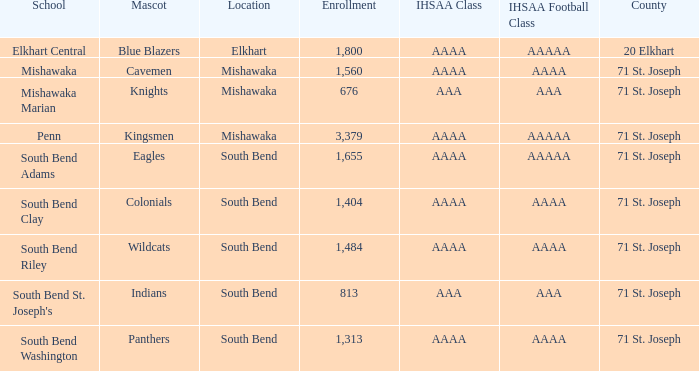What location has an enrollment greater than 1,313, and kingsmen as the mascot? Mishawaka. 